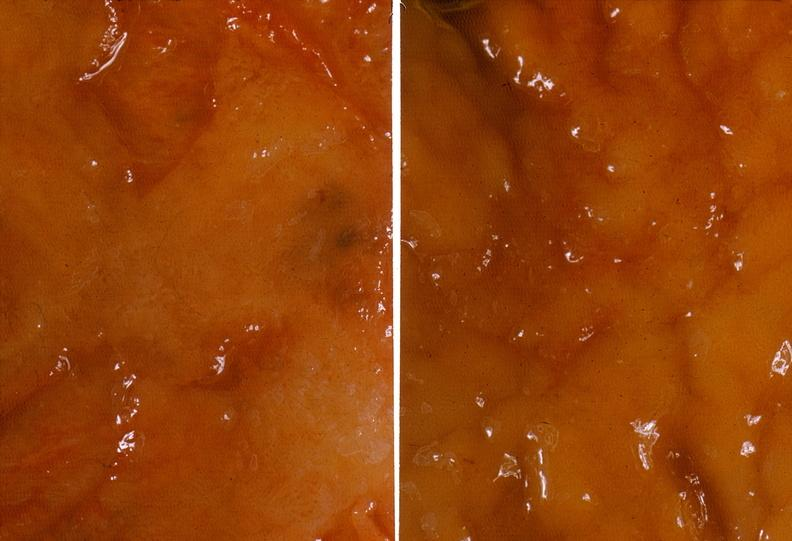what does this image show?
Answer the question using a single word or phrase. Colon 